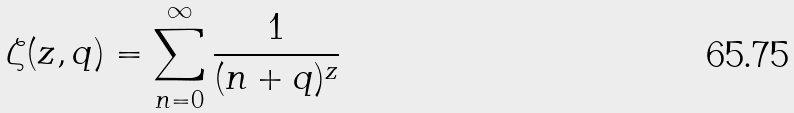<formula> <loc_0><loc_0><loc_500><loc_500>\zeta ( z , q ) = \sum _ { n = 0 } ^ { \infty } \frac { 1 } { ( n + q ) ^ { z } }</formula> 